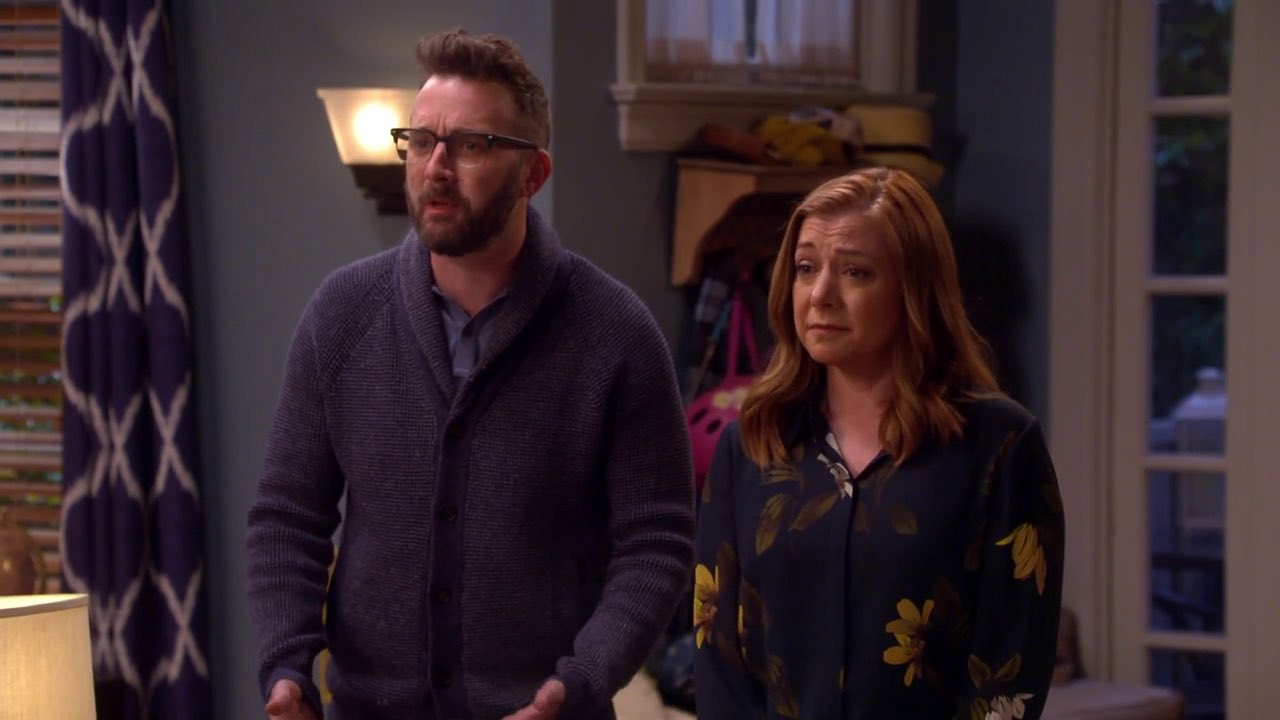Imagine the wildest scenario happening right now. In an unexpected twist, the individuals are watching as a portal to another dimension opens up in their living room. Through the swirling vortex, they can see fantastical creatures and alien landscapes. Their concern isn't just for the immediate shock but also the possibilities that this strange phenomenon brings, altering their perception of reality forever! 